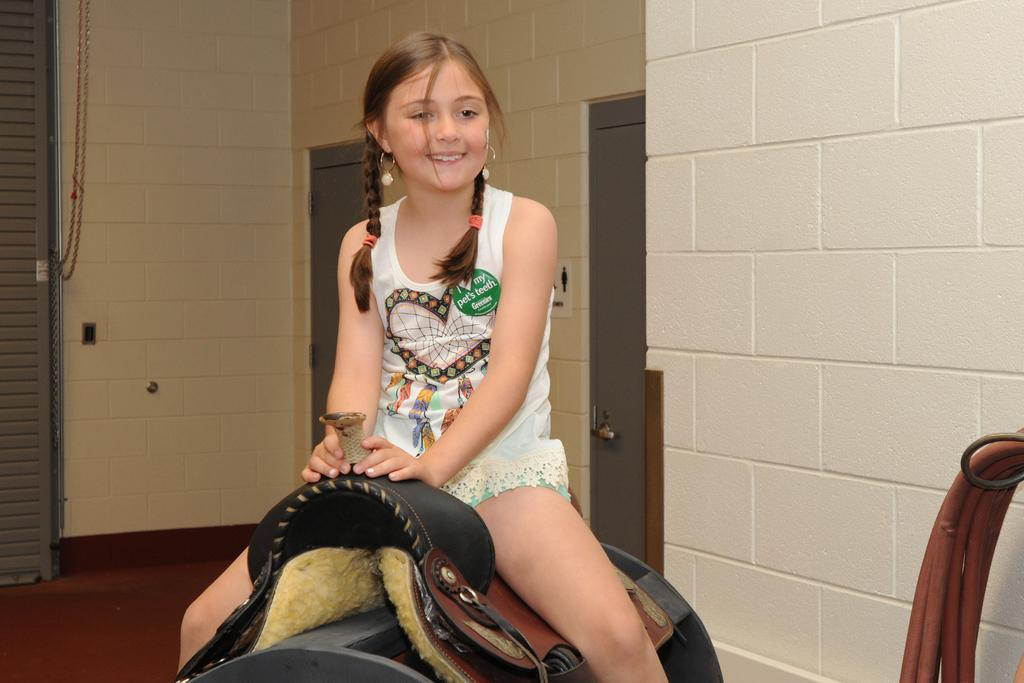What type of room is shown in the image? The image shows an inner view of a room. What is the girl in the room doing? The girl is seated on a saddle in the room. What is the girl's facial expression? The girl has a smile on her face. How many doors can be seen in the room? There are at least two doors visible in the room. What is located on the side of the room? There is a pipe on the side of the room. Can you see a ship in the room? No, there is no ship present in the room. Is there a sink in the room? The provided facts do not mention a sink in the room. Is there a boy in the room? The provided facts only mention a girl in the room, so there is no information about a boy. 